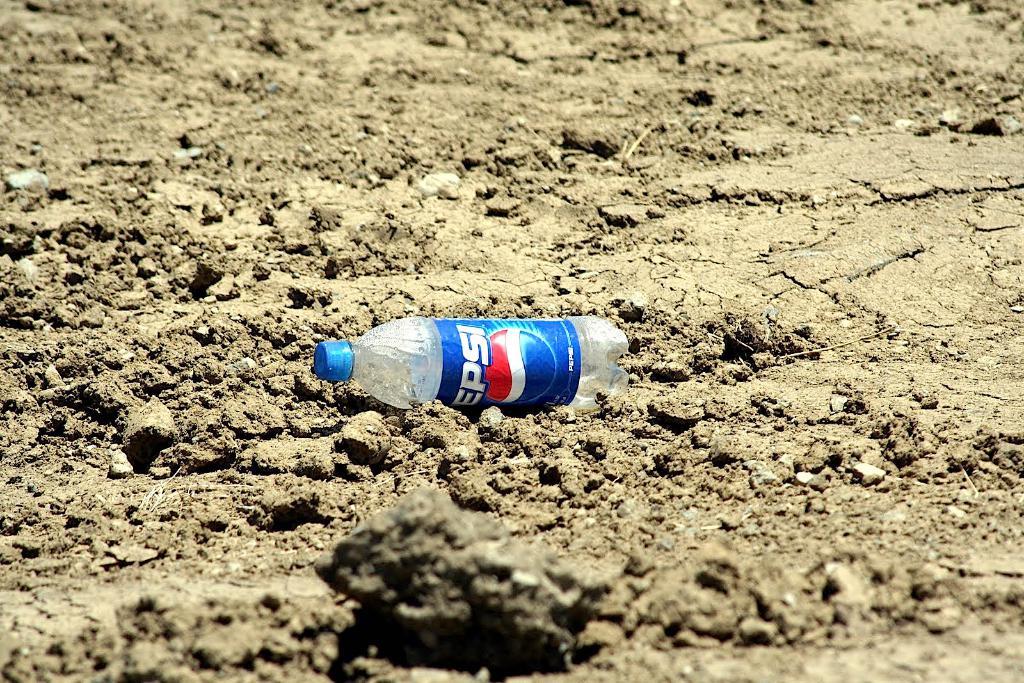What kind of drink was in this bottle?
Provide a short and direct response. Pepsi. What color is the word pepsi?
Your answer should be compact. White. 